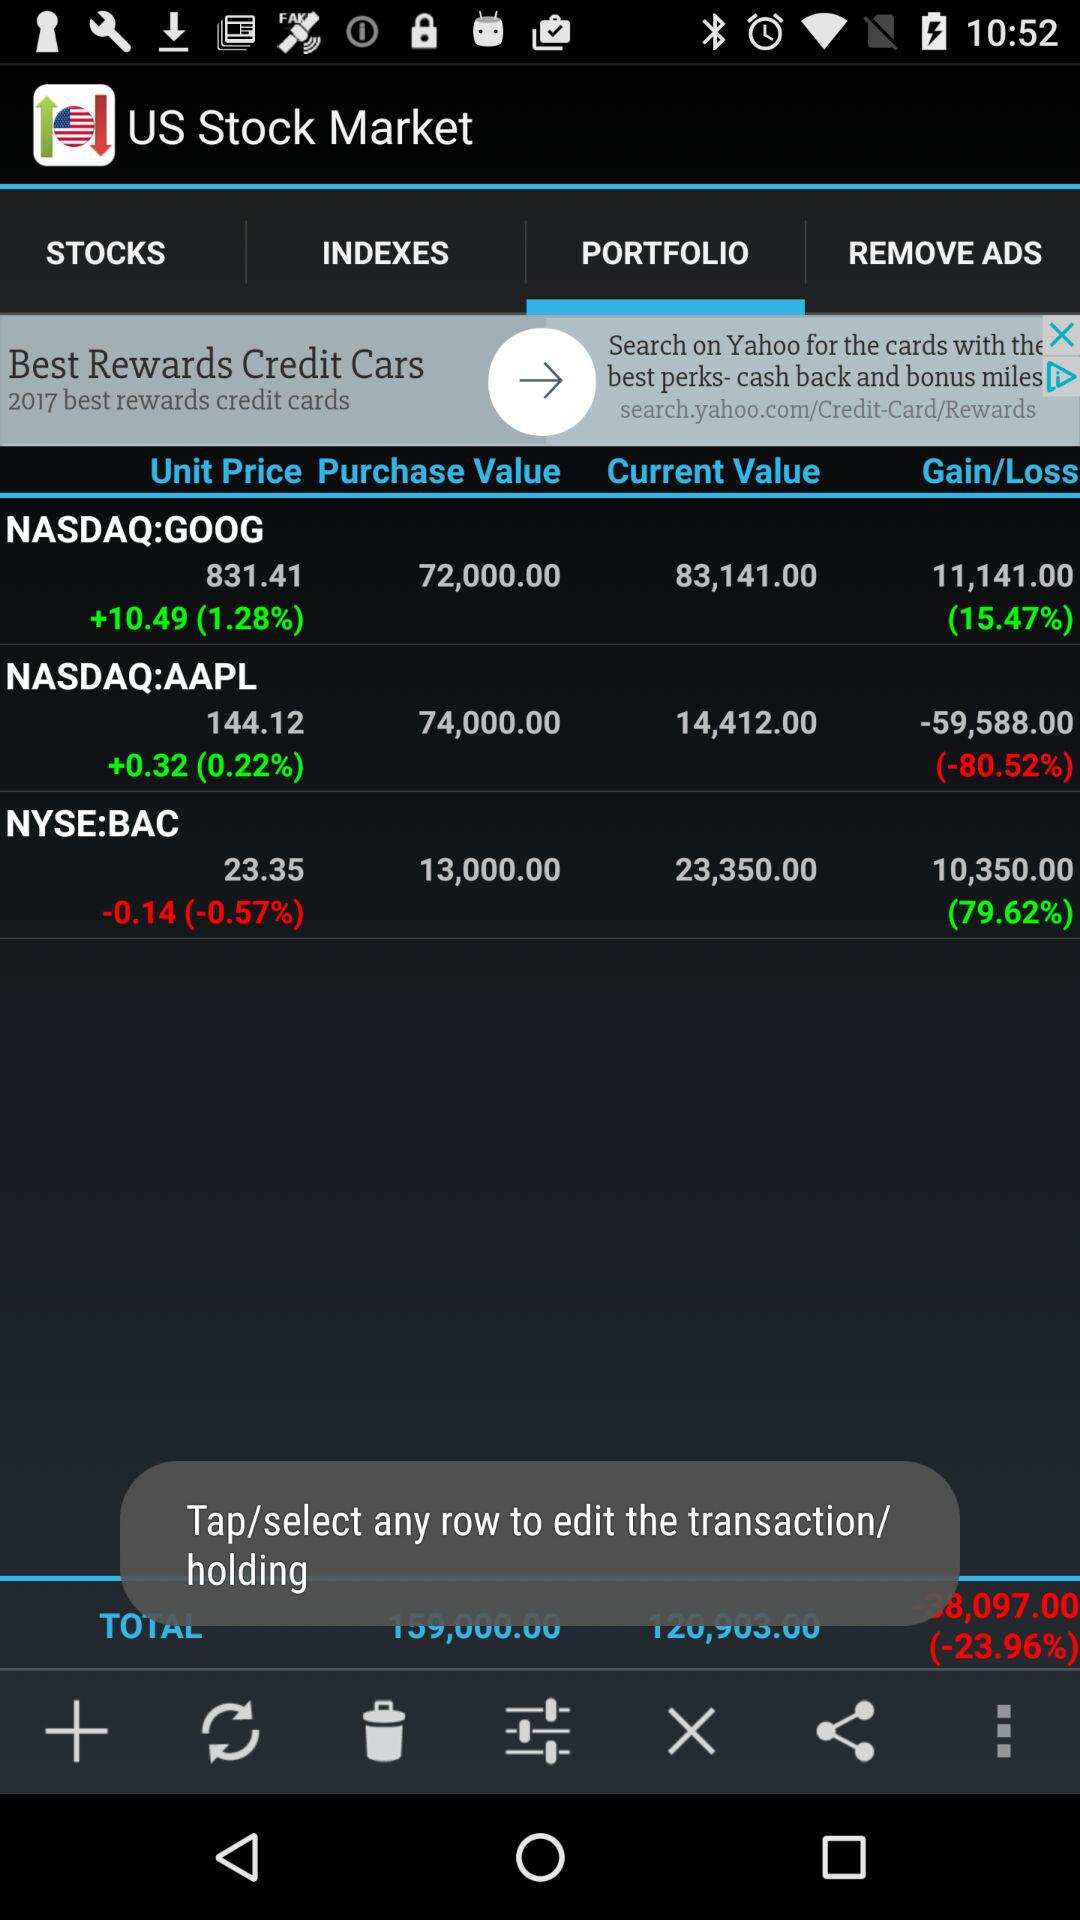What is the gain percentage of "NASDAQ:GOOG"? The gain percentage is 15.47. 